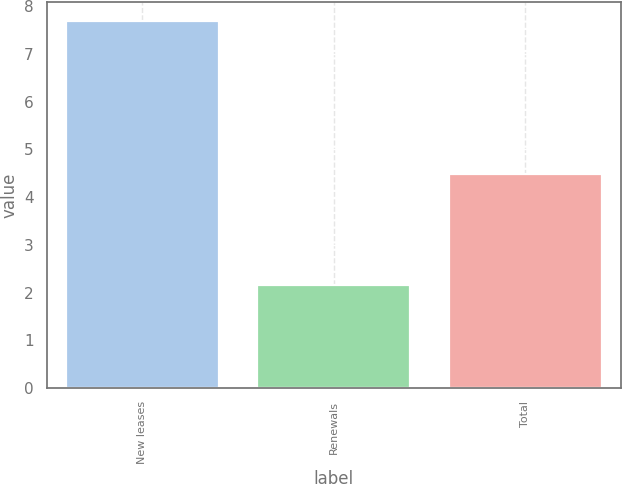Convert chart to OTSL. <chart><loc_0><loc_0><loc_500><loc_500><bar_chart><fcel>New leases<fcel>Renewals<fcel>Total<nl><fcel>7.7<fcel>2.15<fcel>4.48<nl></chart> 